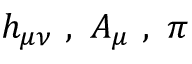Convert formula to latex. <formula><loc_0><loc_0><loc_500><loc_500>h _ { \mu \nu } \ , \ A _ { \mu } \ , \ \pi</formula> 